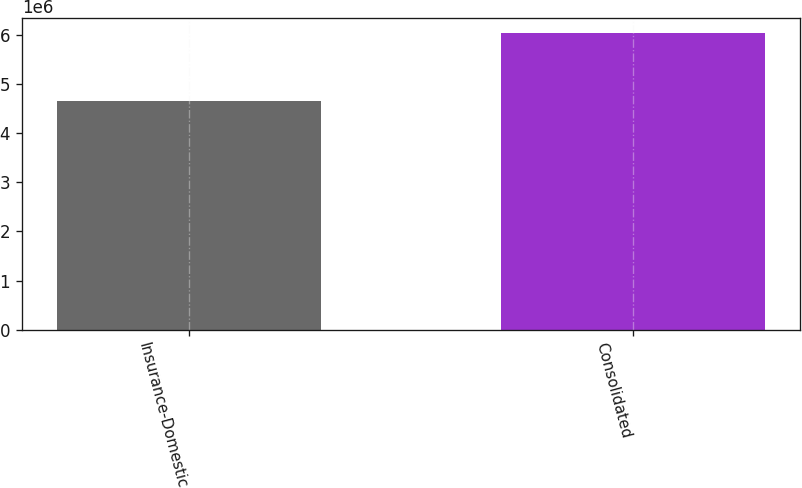Convert chart to OTSL. <chart><loc_0><loc_0><loc_500><loc_500><bar_chart><fcel>Insurance-Domestic<fcel>Consolidated<nl><fcel>4.65936e+06<fcel>6.04061e+06<nl></chart> 